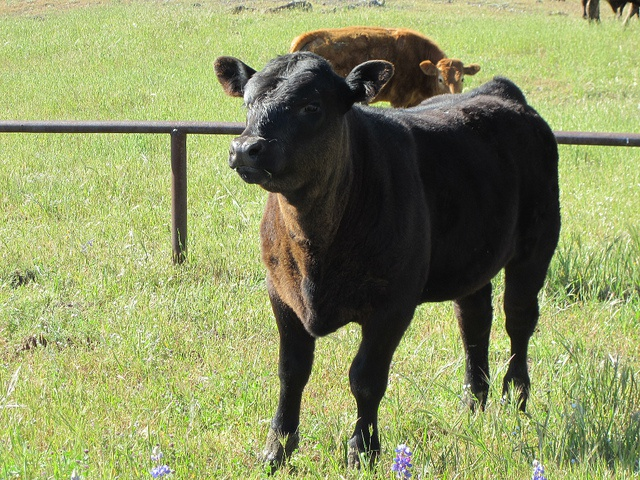Describe the objects in this image and their specific colors. I can see cow in tan, black, gray, and darkgray tones, cow in tan, black, and maroon tones, and cow in tan, black, olive, darkgreen, and gray tones in this image. 